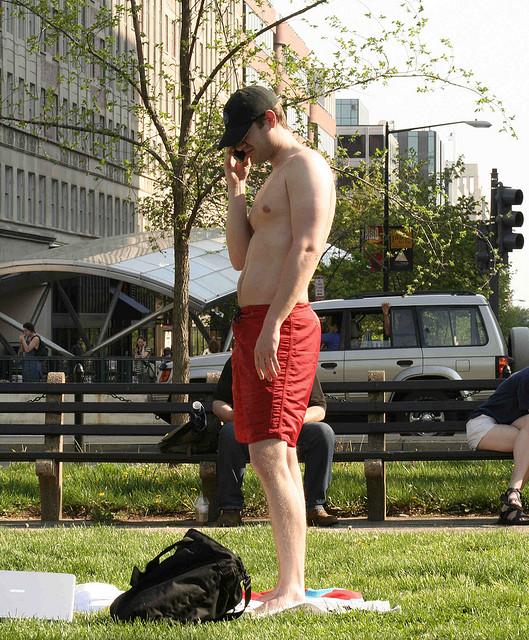Does the person in the photo feel hot?
Keep it brief. Yes. Is this person fat?
Be succinct. No. What color shorts does this guy have on?
Give a very brief answer. Red. 